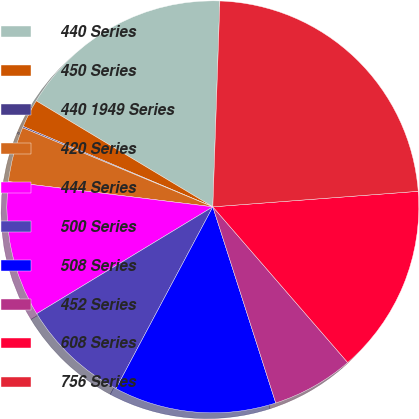Convert chart to OTSL. <chart><loc_0><loc_0><loc_500><loc_500><pie_chart><fcel>440 Series<fcel>450 Series<fcel>440 1949 Series<fcel>420 Series<fcel>444 Series<fcel>500 Series<fcel>508 Series<fcel>452 Series<fcel>608 Series<fcel>756 Series<nl><fcel>16.94%<fcel>2.22%<fcel>0.11%<fcel>4.32%<fcel>10.63%<fcel>8.53%<fcel>12.73%<fcel>6.42%<fcel>14.84%<fcel>23.25%<nl></chart> 